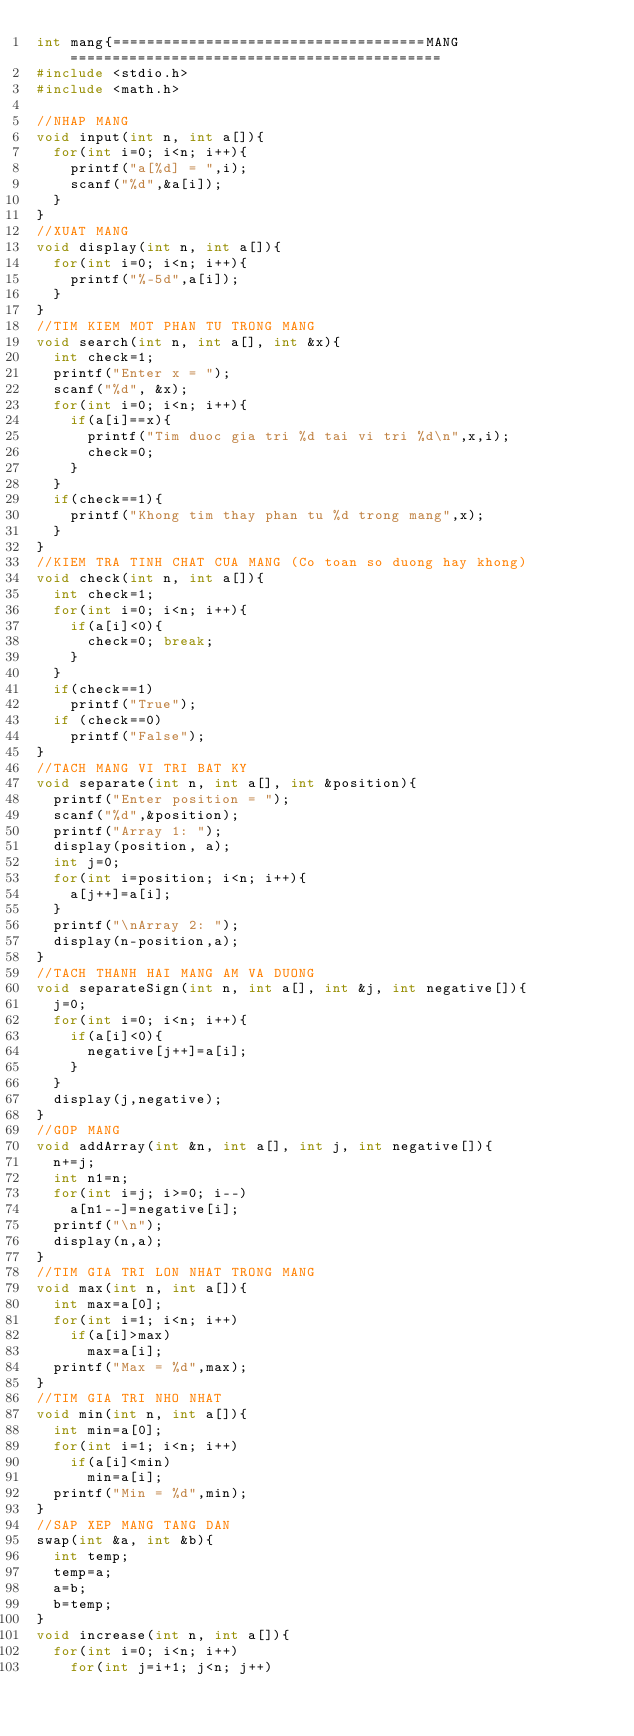Convert code to text. <code><loc_0><loc_0><loc_500><loc_500><_C_>int mang{=====================================MANG============================================
#include <stdio.h>
#include <math.h>

//NHAP MANG
void input(int n, int a[]){
	for(int i=0; i<n; i++){
		printf("a[%d] = ",i);
		scanf("%d",&a[i]);
	}
}
//XUAT MANG
void display(int n, int a[]){
	for(int i=0; i<n; i++){
		printf("%-5d",a[i]);
	}
}
//TIM KIEM MOT PHAN TU TRONG MANG
void search(int n, int a[], int &x){
	int check=1;
	printf("Enter x = ");
	scanf("%d", &x);
	for(int i=0; i<n; i++){
		if(a[i]==x){
			printf("Tim duoc gia tri %d tai vi tri %d\n",x,i);
			check=0;
		}
	}
	if(check==1){
		printf("Khong tim thay phan tu %d trong mang",x);
	}
}
//KIEM TRA TINH CHAT CUA MANG (Co toan so duong hay khong)
void check(int n, int a[]){
	int check=1;
	for(int i=0; i<n; i++){
		if(a[i]<0){
			check=0; break;
		}
	}
	if(check==1) 
		printf("True");
	if (check==0)
		printf("False");
}
//TACH MANG VI TRI BAT KY
void separate(int n, int a[], int &position){
	printf("Enter position = ");
	scanf("%d",&position);
	printf("Array 1: ");
	display(position, a);
	int j=0;
	for(int i=position; i<n; i++){
		a[j++]=a[i];
	}
	printf("\nArray 2: ");
	display(n-position,a);
}
//TACH THANH HAI MANG AM VA DUONG
void separateSign(int n, int a[], int &j, int negative[]){
	j=0;
	for(int i=0; i<n; i++){
		if(a[i]<0){
			negative[j++]=a[i];
		} 
	}
	display(j,negative);
}
//GOP MANG
void addArray(int &n, int a[], int j, int negative[]){
	n+=j;
	int n1=n;
	for(int i=j; i>=0; i--)
		a[n1--]=negative[i];
	printf("\n");
	display(n,a);
}
//TIM GIA TRI LON NHAT TRONG MANG
void max(int n, int a[]){
	int max=a[0];
	for(int i=1; i<n; i++)
		if(a[i]>max)
			max=a[i];
	printf("Max = %d",max);
}
//TIM GIA TRI NHO NHAT
void min(int n, int a[]){
	int min=a[0];
	for(int i=1; i<n; i++)
		if(a[i]<min)
			min=a[i];
	printf("Min = %d",min);
}
//SAP XEP MANG TANG DAN
swap(int &a, int &b){
	int temp;
	temp=a;
	a=b;
	b=temp;
}
void increase(int n, int a[]){
	for(int i=0; i<n; i++)
		for(int j=i+1; j<n; j++)</code> 